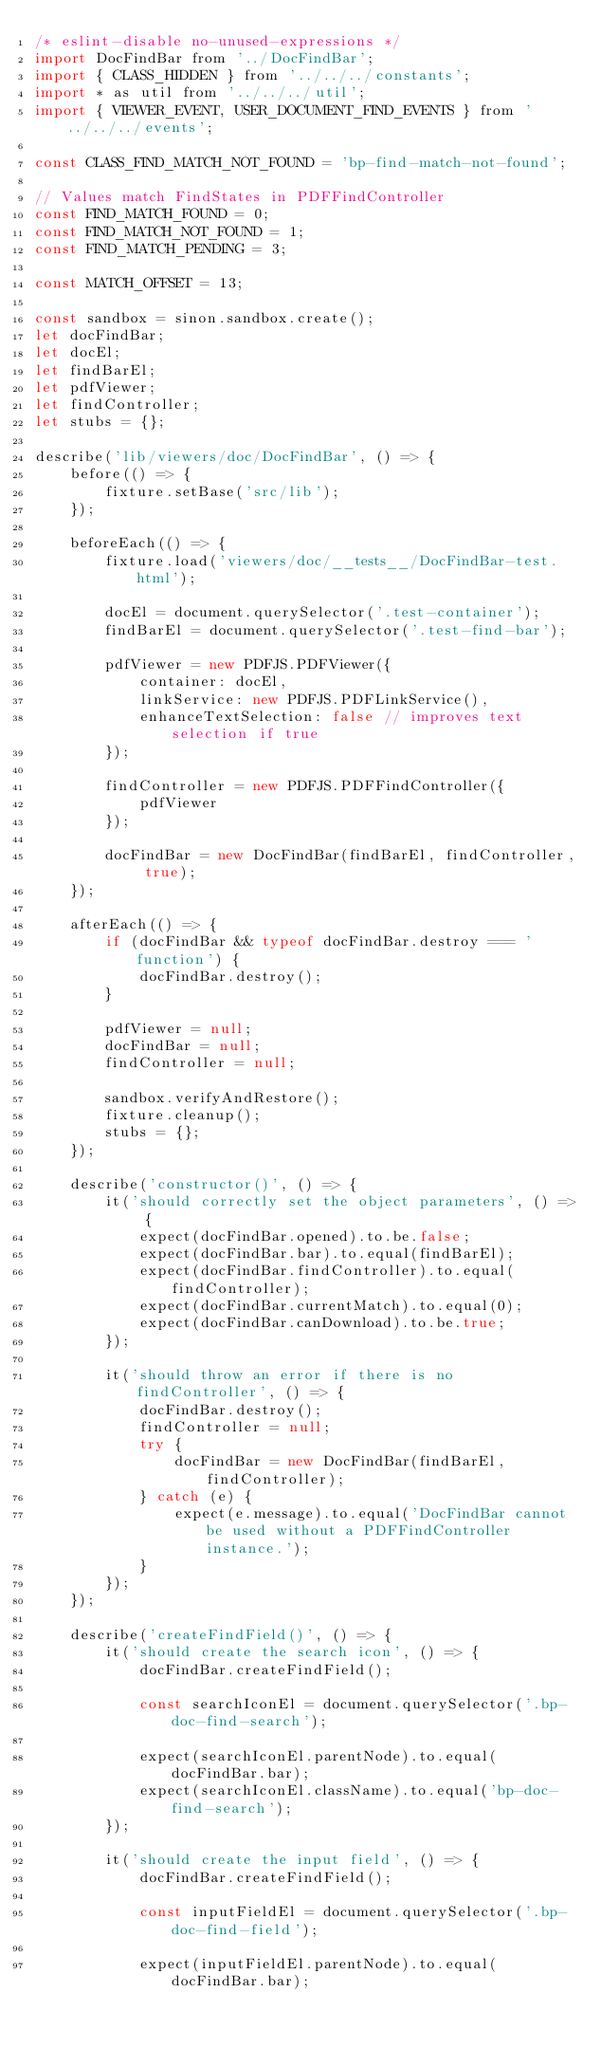<code> <loc_0><loc_0><loc_500><loc_500><_JavaScript_>/* eslint-disable no-unused-expressions */
import DocFindBar from '../DocFindBar';
import { CLASS_HIDDEN } from '../../../constants';
import * as util from '../../../util';
import { VIEWER_EVENT, USER_DOCUMENT_FIND_EVENTS } from '../../../events';

const CLASS_FIND_MATCH_NOT_FOUND = 'bp-find-match-not-found';

// Values match FindStates in PDFFindController
const FIND_MATCH_FOUND = 0;
const FIND_MATCH_NOT_FOUND = 1;
const FIND_MATCH_PENDING = 3;

const MATCH_OFFSET = 13;

const sandbox = sinon.sandbox.create();
let docFindBar;
let docEl;
let findBarEl;
let pdfViewer;
let findController;
let stubs = {};

describe('lib/viewers/doc/DocFindBar', () => {
    before(() => {
        fixture.setBase('src/lib');
    });

    beforeEach(() => {
        fixture.load('viewers/doc/__tests__/DocFindBar-test.html');

        docEl = document.querySelector('.test-container');
        findBarEl = document.querySelector('.test-find-bar');

        pdfViewer = new PDFJS.PDFViewer({
            container: docEl,
            linkService: new PDFJS.PDFLinkService(),
            enhanceTextSelection: false // improves text selection if true
        });

        findController = new PDFJS.PDFFindController({
            pdfViewer
        });

        docFindBar = new DocFindBar(findBarEl, findController, true);
    });

    afterEach(() => {
        if (docFindBar && typeof docFindBar.destroy === 'function') {
            docFindBar.destroy();
        }

        pdfViewer = null;
        docFindBar = null;
        findController = null;

        sandbox.verifyAndRestore();
        fixture.cleanup();
        stubs = {};
    });

    describe('constructor()', () => {
        it('should correctly set the object parameters', () => {
            expect(docFindBar.opened).to.be.false;
            expect(docFindBar.bar).to.equal(findBarEl);
            expect(docFindBar.findController).to.equal(findController);
            expect(docFindBar.currentMatch).to.equal(0);
            expect(docFindBar.canDownload).to.be.true;
        });

        it('should throw an error if there is no findController', () => {
            docFindBar.destroy();
            findController = null;
            try {
                docFindBar = new DocFindBar(findBarEl, findController);
            } catch (e) {
                expect(e.message).to.equal('DocFindBar cannot be used without a PDFFindController instance.');
            }
        });
    });

    describe('createFindField()', () => {
        it('should create the search icon', () => {
            docFindBar.createFindField();

            const searchIconEl = document.querySelector('.bp-doc-find-search');

            expect(searchIconEl.parentNode).to.equal(docFindBar.bar);
            expect(searchIconEl.className).to.equal('bp-doc-find-search');
        });

        it('should create the input field', () => {
            docFindBar.createFindField();

            const inputFieldEl = document.querySelector('.bp-doc-find-field');

            expect(inputFieldEl.parentNode).to.equal(docFindBar.bar);</code> 